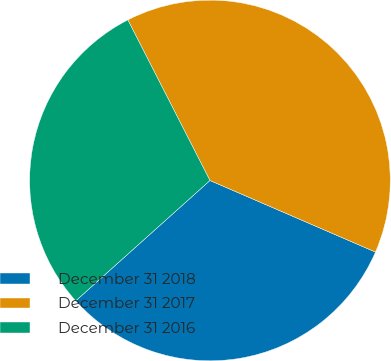Convert chart. <chart><loc_0><loc_0><loc_500><loc_500><pie_chart><fcel>December 31 2018<fcel>December 31 2017<fcel>December 31 2016<nl><fcel>31.87%<fcel>39.02%<fcel>29.11%<nl></chart> 